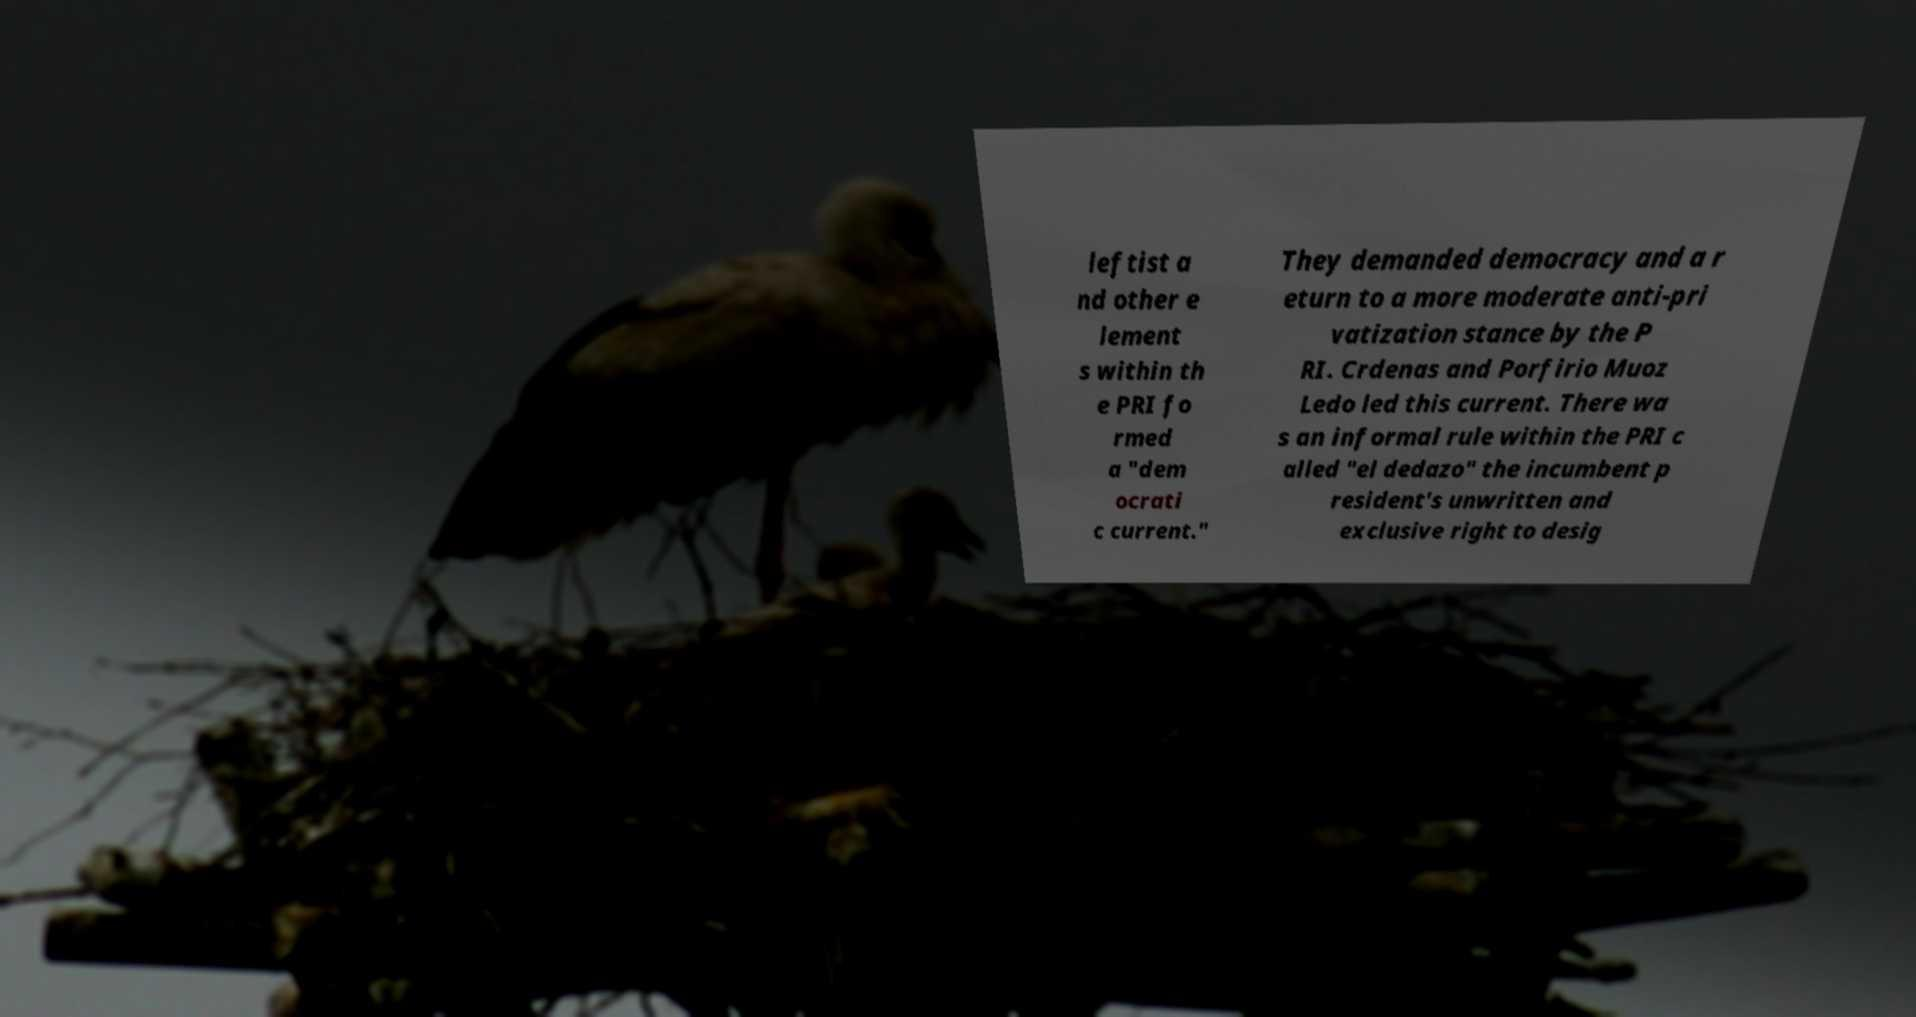I need the written content from this picture converted into text. Can you do that? leftist a nd other e lement s within th e PRI fo rmed a "dem ocrati c current." They demanded democracy and a r eturn to a more moderate anti-pri vatization stance by the P RI. Crdenas and Porfirio Muoz Ledo led this current. There wa s an informal rule within the PRI c alled "el dedazo" the incumbent p resident's unwritten and exclusive right to desig 